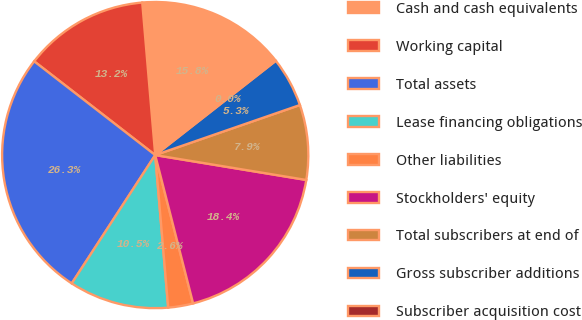<chart> <loc_0><loc_0><loc_500><loc_500><pie_chart><fcel>Cash and cash equivalents<fcel>Working capital<fcel>Total assets<fcel>Lease financing obligations<fcel>Other liabilities<fcel>Stockholders' equity<fcel>Total subscribers at end of<fcel>Gross subscriber additions<fcel>Subscriber acquisition cost<nl><fcel>15.79%<fcel>13.16%<fcel>26.31%<fcel>10.53%<fcel>2.63%<fcel>18.42%<fcel>7.9%<fcel>5.26%<fcel>0.0%<nl></chart> 